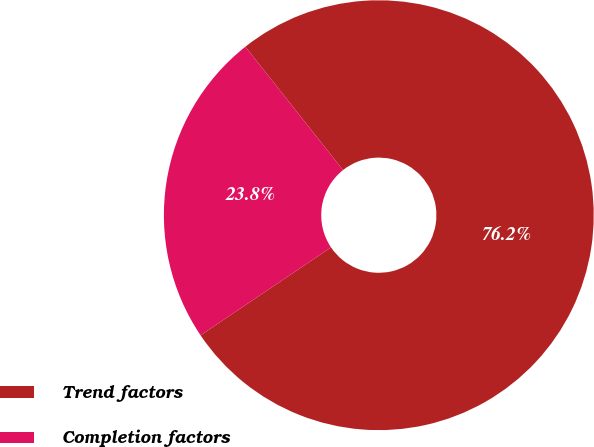Convert chart to OTSL. <chart><loc_0><loc_0><loc_500><loc_500><pie_chart><fcel>Trend factors<fcel>Completion factors<nl><fcel>76.23%<fcel>23.77%<nl></chart> 